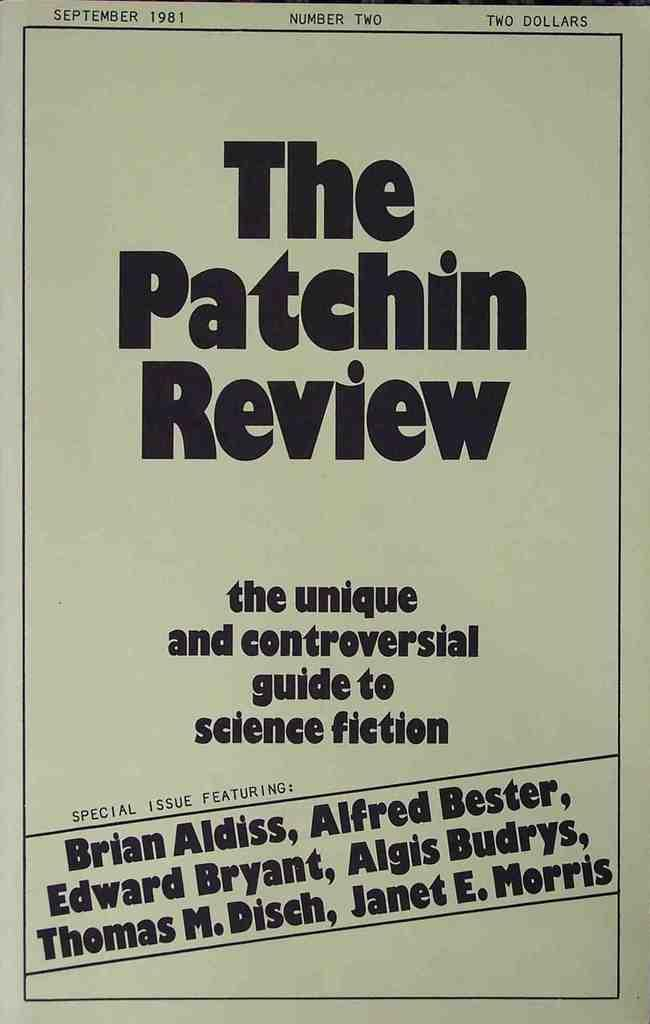<image>
Give a short and clear explanation of the subsequent image. A poster that says The Patchin Review from September 1981. 